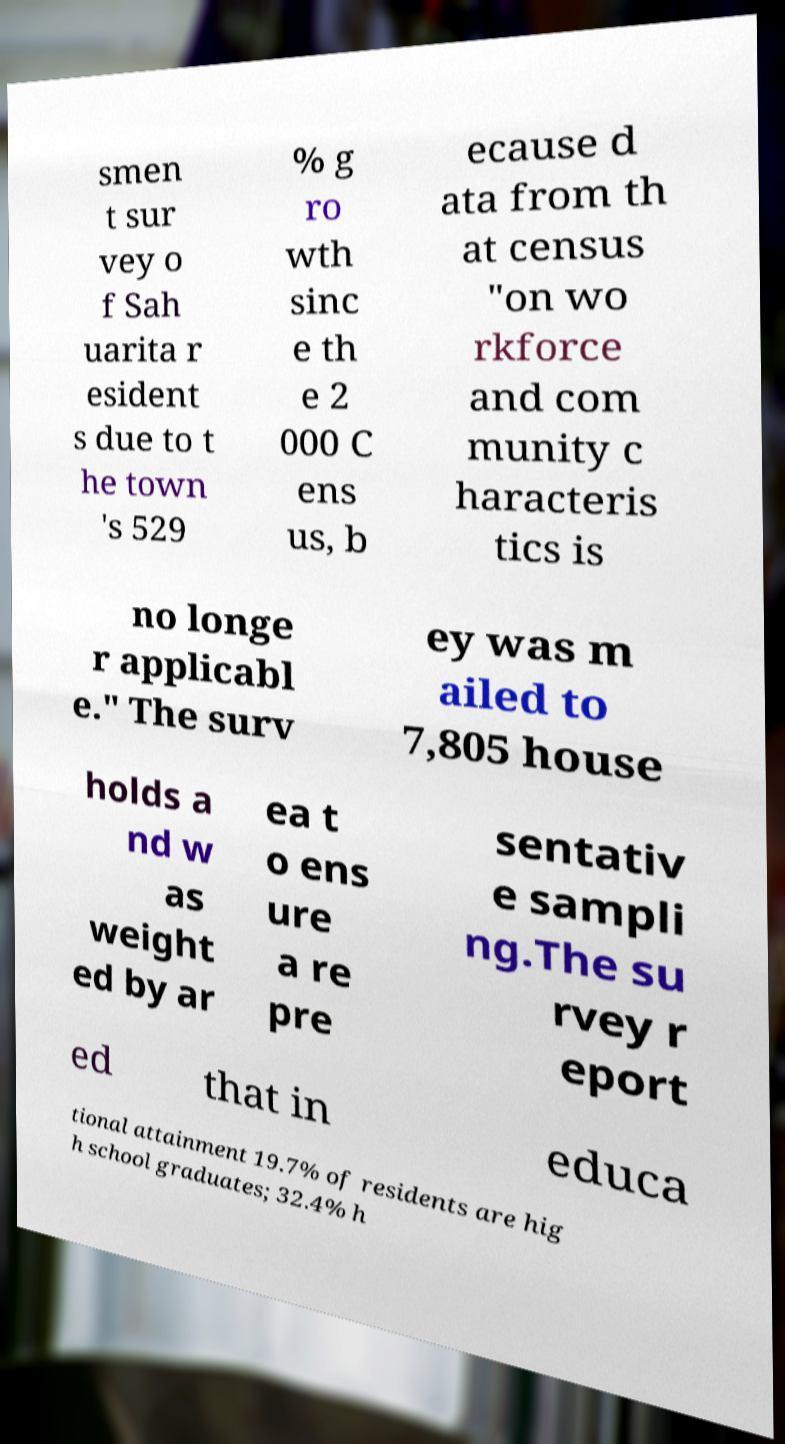Could you extract and type out the text from this image? smen t sur vey o f Sah uarita r esident s due to t he town 's 529 % g ro wth sinc e th e 2 000 C ens us, b ecause d ata from th at census "on wo rkforce and com munity c haracteris tics is no longe r applicabl e." The surv ey was m ailed to 7,805 house holds a nd w as weight ed by ar ea t o ens ure a re pre sentativ e sampli ng.The su rvey r eport ed that in educa tional attainment 19.7% of residents are hig h school graduates; 32.4% h 